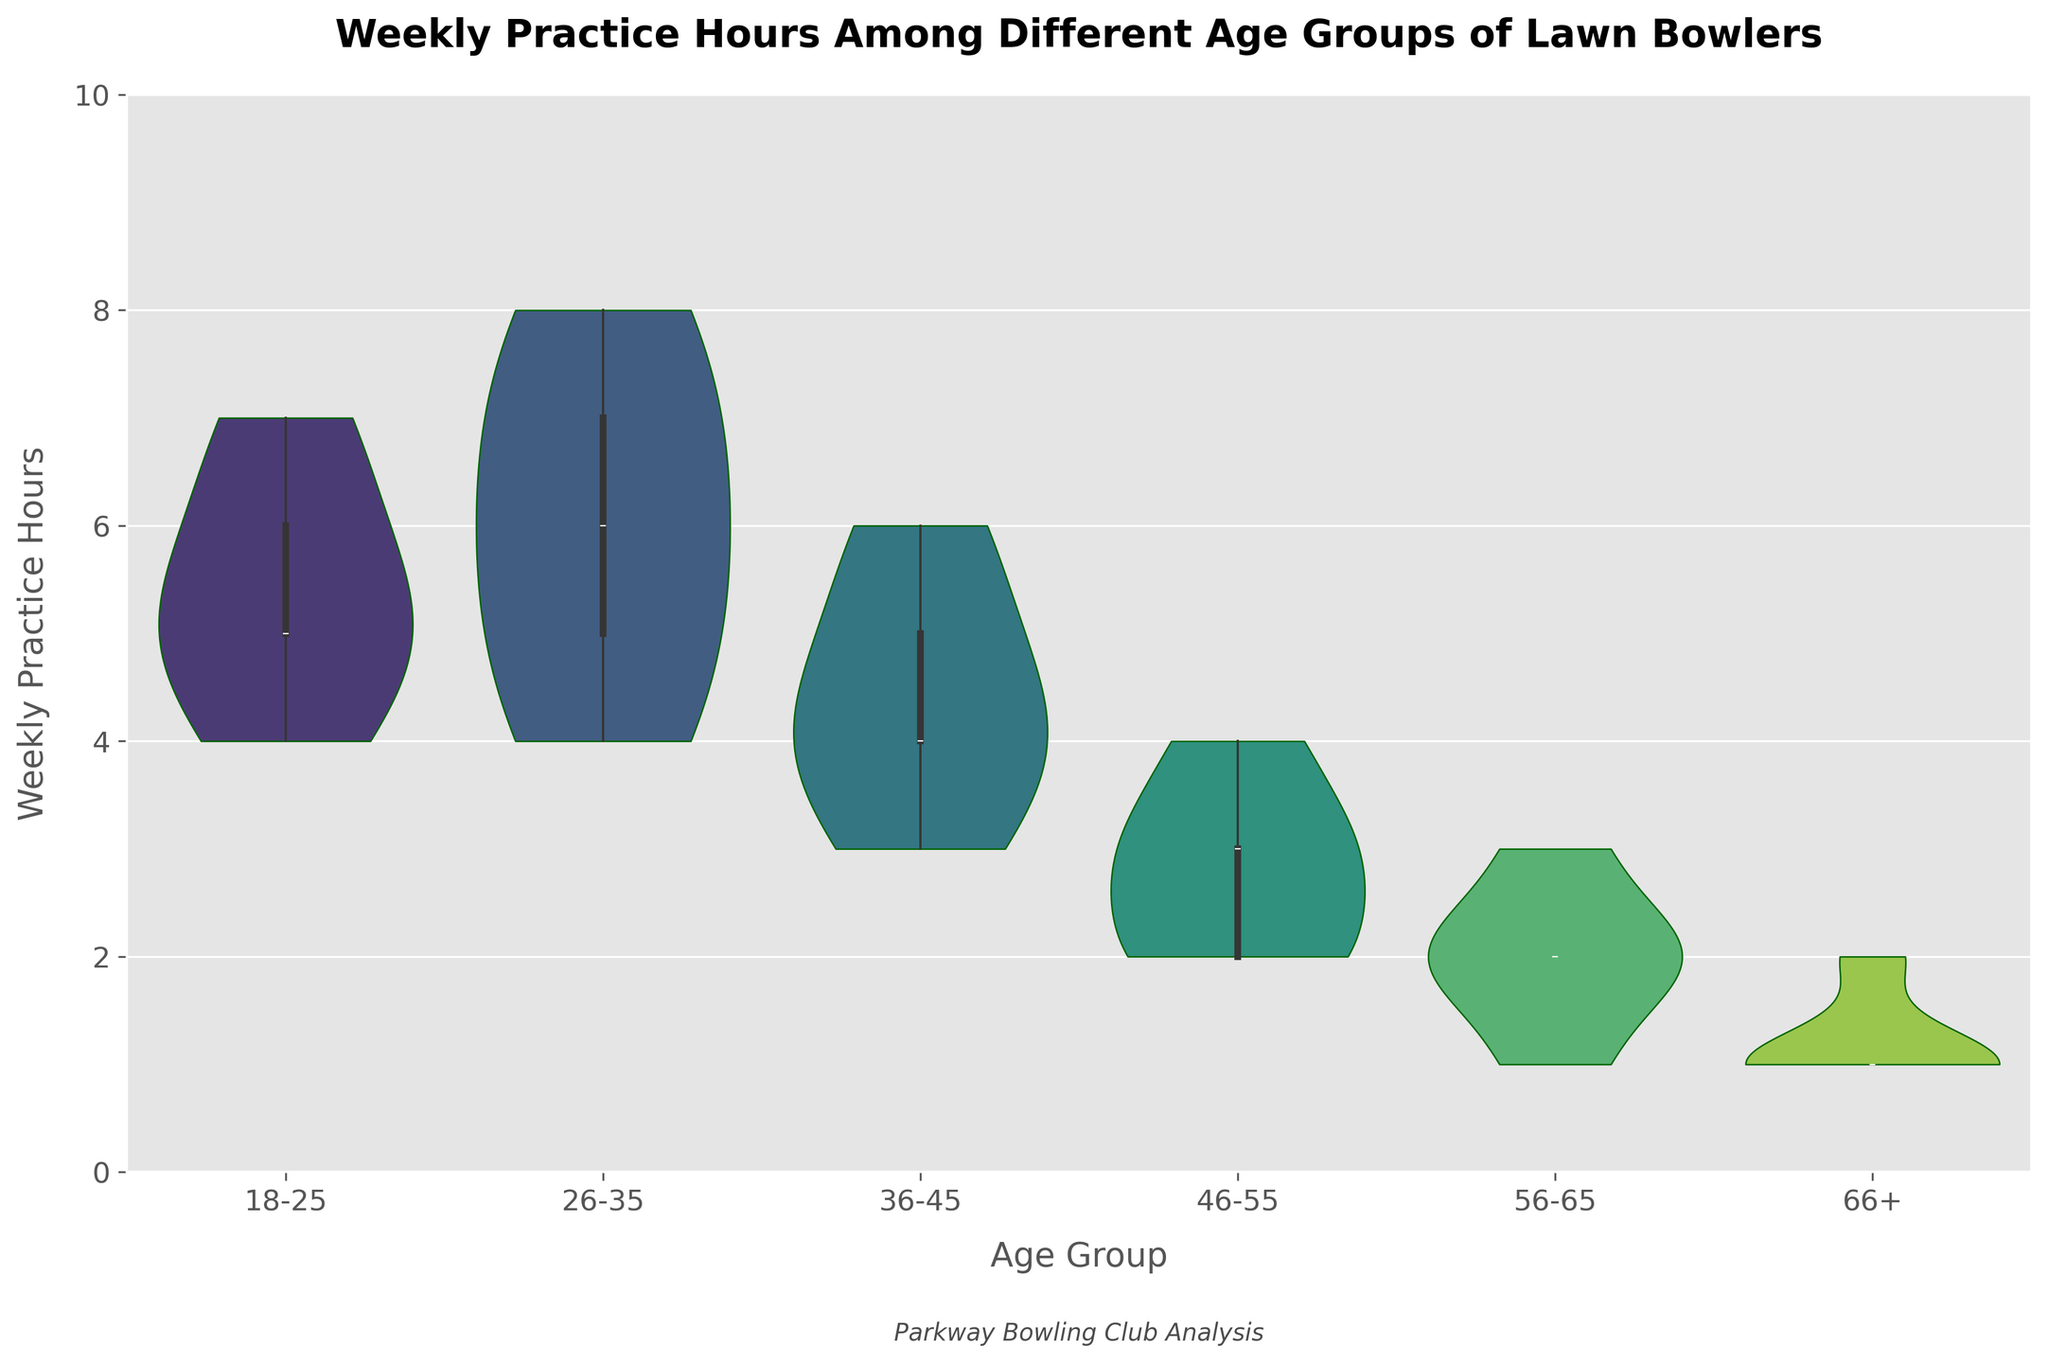What is the range of weekly practice hours for the age group 18-25? The violin chart visually represents the distribution of weekly practice hours for each age group. For the 18-25 age group, the plot extends from the minimum to the maximum value of practice hours. The data points for the 18-25 age group range from 4 to 7 hours.
Answer: 4 to 7 hours Which age group has the widest distribution of weekly practice hours? Examining the width and spread of each violin plot, we notice that the 26-35 age group has practice hours distributed across a broader range, from 4 to 8 hours, compared to the other age groups.
Answer: 26-35 What's the median weekly practice hours for the age group 66+? The inner box plot of the violin chart shows the median as a line in the middle of the distribution. For the 66+ age group, the median weekly practice hours are marked at 1 hour.
Answer: 1 hour How do the weekly practice hours change as age increases? By examining the violin plots from left to right (youngest to oldest), we can observe that the practice hours generally decrease. Younger groups (18-25, 26-35) have higher and wider distributions while the older groups (56-65, 66+) have lower and narrower distributions.
Answer: Decrease What are the most common weekly practice hours for the age group 46-55? The density of the violin plot shows where the values cluster. For the 46-55 age group, the practice hours most commonly cluster around 3 hours, as indicated by the peak of the plot.
Answer: 3 hours Which age group practices the least on average per week? By examining the central tendency and the median lines in the violin plots, the 66+ age group has the lowest median value (1 hour) and also a narrow spread around this value, indicating they practice the least.
Answer: 66+ Is there any age group with a symmetric distribution? A symmetric distribution is indicated by a violin plot which has even spread on both sides of the median line. The 18-25 and 46-55 age groups have relatively symmetric distributions around their median values.
Answer: 18-25, 46-55 Compare the practice hours range between the 26-35 and 36-45 age groups The 26-35 age group has a range from 4 to 8 hours, whereas the 36-45 age group ranges from 3 to 6 hours. The 26-35 group has a wider and higher range compared to the 36-45 group.
Answer: 26-35: 4 to 8 hours, 36-45: 3 to 6 hours Which age group shows the least variation in practice hours? The violin plot for the 66+ age group has the narrowest spread, indicating the least variation in weekly practice hours. Most of the data points are clustered around 1 hour with very little deviation.
Answer: 66+ 